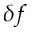Convert formula to latex. <formula><loc_0><loc_0><loc_500><loc_500>\delta f</formula> 